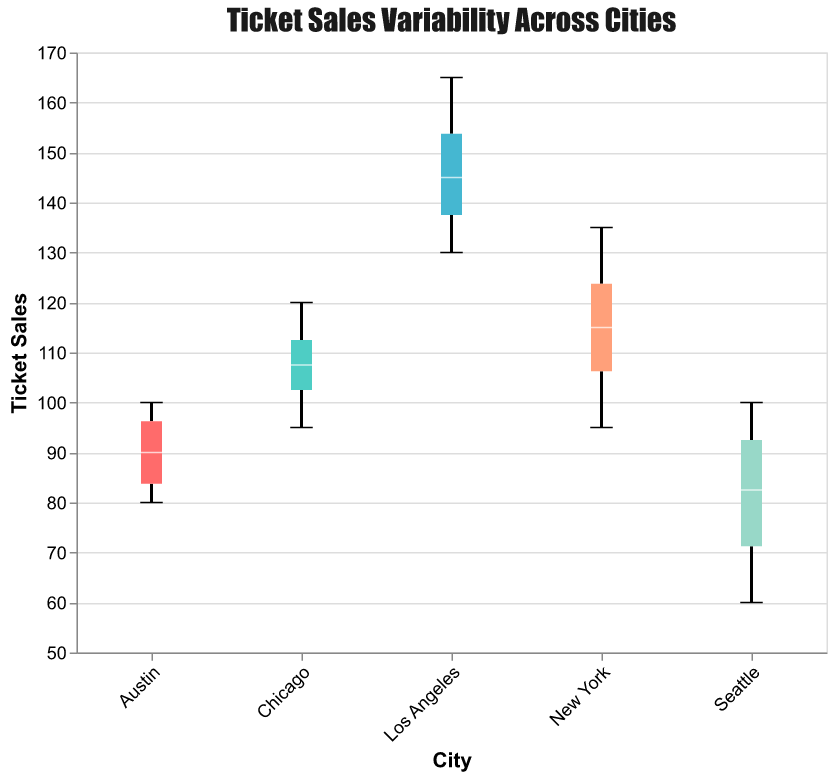What's the title of the figure? The title is displayed at the top of the figure, indicating the main focus of the plot, which is "Ticket Sales Variability Across Cities."
Answer: Ticket Sales Variability Across Cities Which city has the highest range of ticket sales? By observing the vertical spread of ticket sales data points for each city, Los Angeles has the largest range of ticket sales from around 130 to 165.
Answer: Los Angeles What is the median ticket sales value for New York? To find the median, look for the line inside the New York box. The median value for New York is around 115.
Answer: 115 Which city has the lowest minimum ticket sales? Seattle has the lowest minimum ticket sales with a value of 60, as indicated by the whisker extending down to 60.
Answer: Seattle What is the interquartile range (IQR) for Chicago? The IQR is the range between the first quartile (bottom of the box) and the third quartile (top of the box) of the ticket sales for Chicago. The IQR for Chicago is approximately from 95 to 120, so the IQR is 120 - 95 = 25.
Answer: 25 Which city has the most consistent ticket sales (smallest variability)? Observing the boxplot width (which represents the spread or variability), Austin has the most consistent ticket sales, with a tight range from around 80 to 100.
Answer: Austin How does the maximum value of ticket sales in Seattle compare to Austin? Compare the whiskers at the top of each boxplot. Seattle's maximum ticket sales are 100, whereas Austin's maximum is around 100. Both cities have similar maximum ticket sales around 100.
Answer: They are similar What is the difference between the median ticket sales of Los Angeles and Austin? Find the median values inside the boxes for Los Angeles and Austin. Los Angeles' median is around 145, and Austin's is around 90. The difference is 145 - 90 = 55.
Answer: 55 Which city has the widest notches on the boxplot? The width of the notch represents the uncertainty about the median. Los Angeles has the widest notches, indicating greater uncertainty around the median value.
Answer: Los Angeles Are there any outliers in the dataset? Outliers are represented as individual data points outside the whiskers. No individual points are plotted outside the whiskers, indicating no outliers in any city's data.
Answer: No 